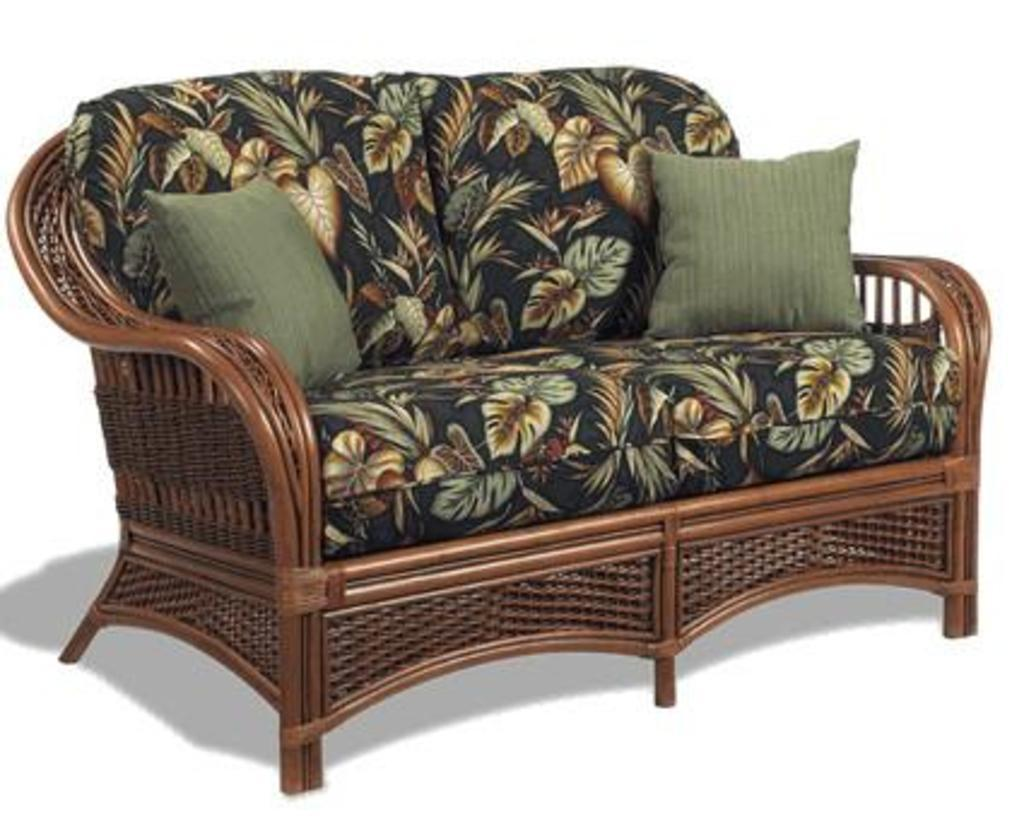What type of furniture is present in the image? There is a couch in the image. Are there any accessories on the couch? Yes, there are two pillows in the image. What type of crime is being committed on the couch in the image? There is no crime or criminal activity depicted in the image; it only shows a couch and two pillows. 